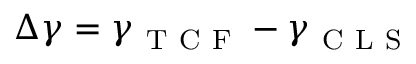Convert formula to latex. <formula><loc_0><loc_0><loc_500><loc_500>\Delta \gamma = \gamma _ { T C F } - \gamma _ { C L S }</formula> 